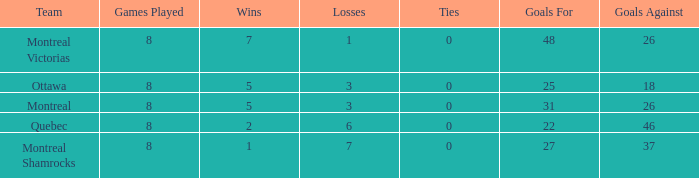How many victories were recorded for teams with over 0 ties and 37 goals conceded? None. 